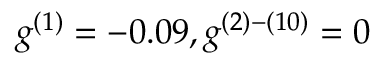Convert formula to latex. <formula><loc_0><loc_0><loc_500><loc_500>g ^ { ( 1 ) } = - 0 . 0 9 , g ^ { ( 2 ) - ( 1 0 ) } = 0</formula> 